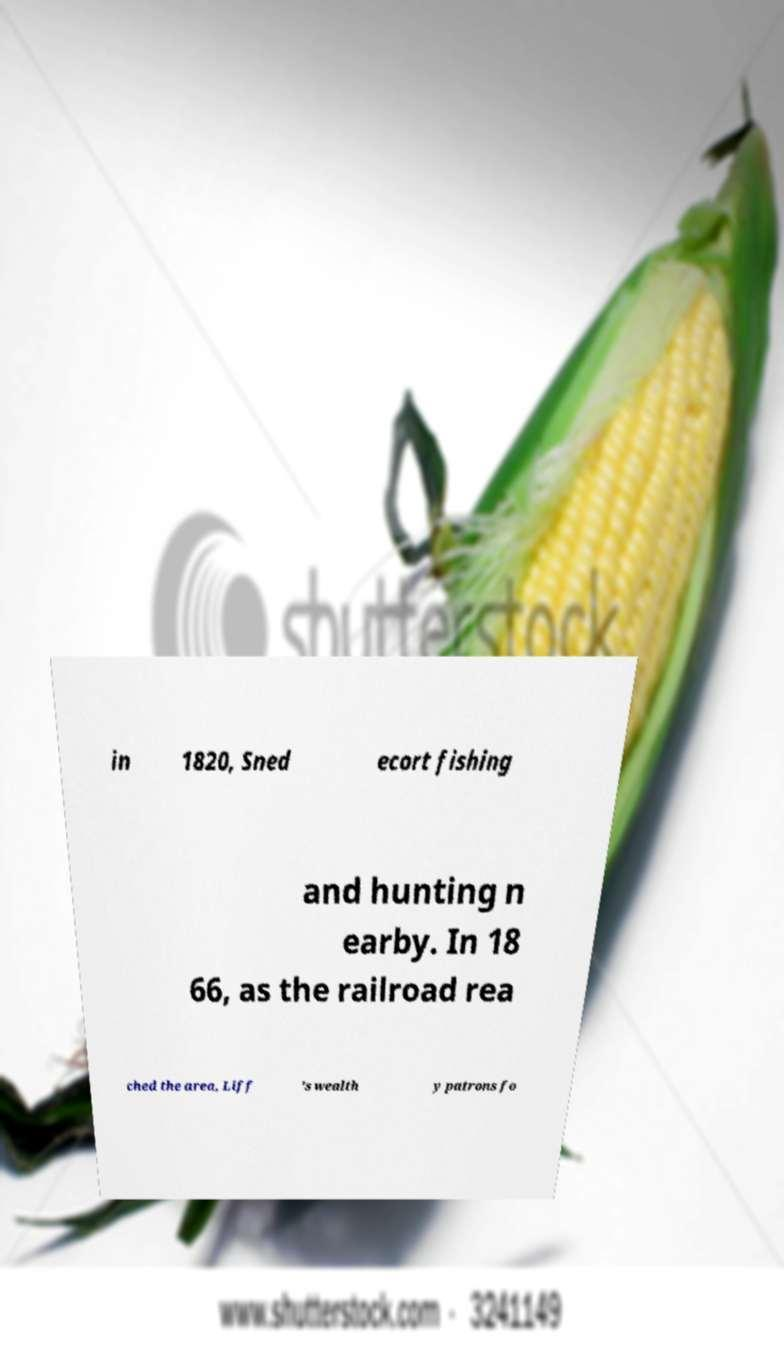Can you accurately transcribe the text from the provided image for me? in 1820, Sned ecort fishing and hunting n earby. In 18 66, as the railroad rea ched the area, Liff 's wealth y patrons fo 